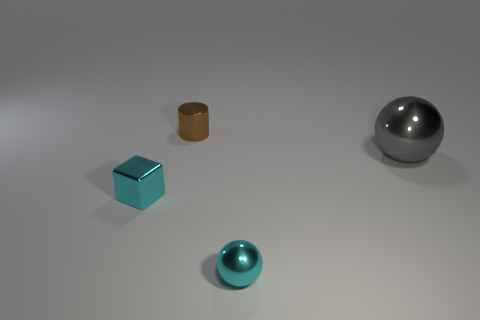Add 1 big cyan rubber cubes. How many objects exist? 5 Subtract all gray balls. How many balls are left? 1 Subtract 1 balls. How many balls are left? 1 Add 3 tiny cyan shiny spheres. How many tiny cyan shiny spheres exist? 4 Subtract 1 cyan blocks. How many objects are left? 3 Subtract all cubes. How many objects are left? 3 Subtract all brown spheres. Subtract all red cylinders. How many spheres are left? 2 Subtract all green rubber things. Subtract all cyan metal blocks. How many objects are left? 3 Add 4 small blocks. How many small blocks are left? 5 